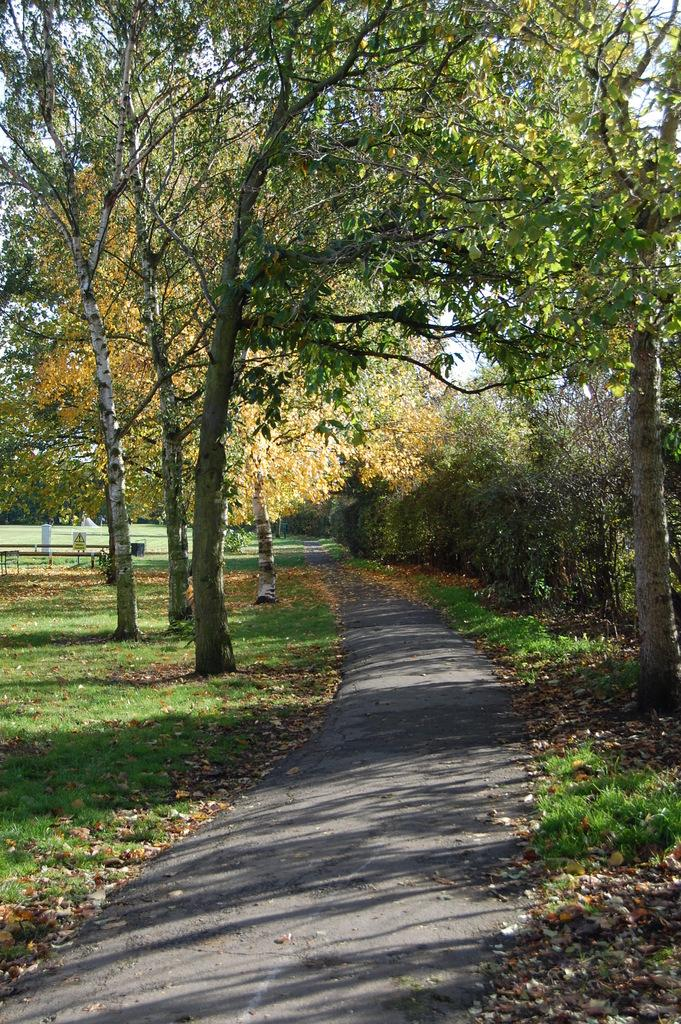What type of vegetation can be seen on either side of the road in the image? There are trees and grass on either side of the road in the image. What is the weather like in the image? It appears to be a sunny day in the image. What can be seen in the sky in the image? The sky is visible in the image. What type of force is being applied to the coal in the image? There is no coal present in the image, so no force is being applied to it. How does the soap interact with the trees on either side of the road in the image? There is no soap present in the image, so it cannot interact with the trees. 